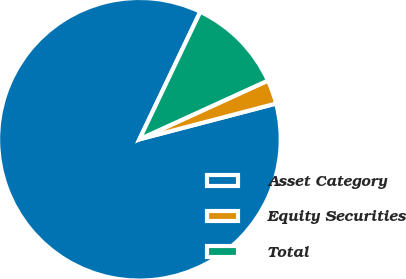<chart> <loc_0><loc_0><loc_500><loc_500><pie_chart><fcel>Asset Category<fcel>Equity Securities<fcel>Total<nl><fcel>86.15%<fcel>2.75%<fcel>11.09%<nl></chart> 